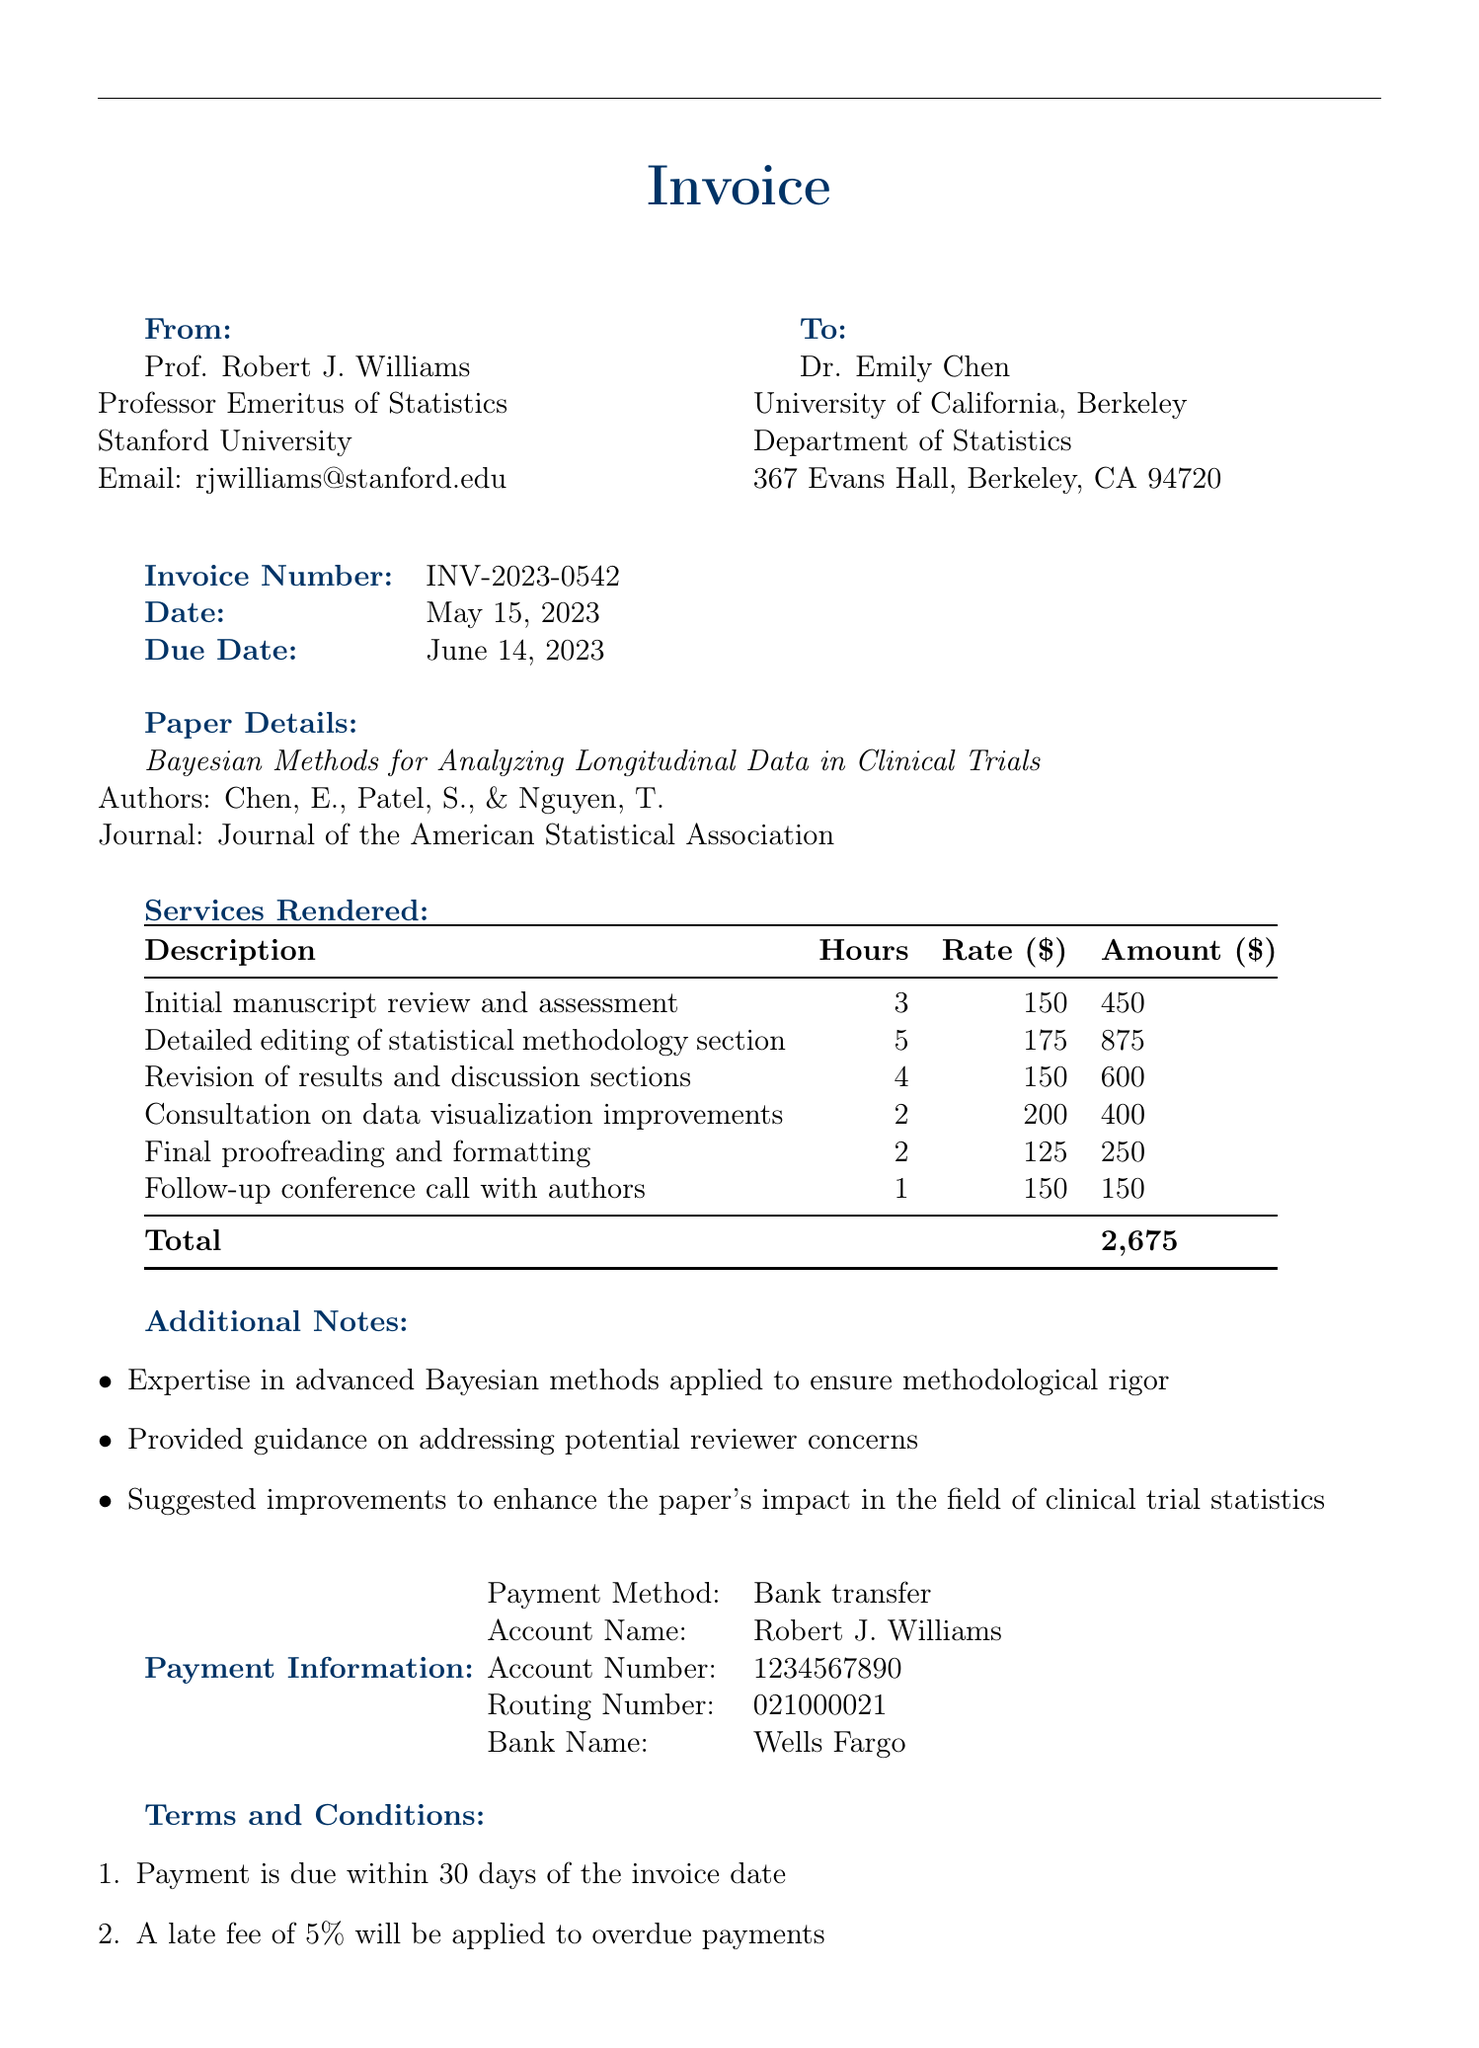What is the invoice number? The invoice number is listed clearly at the top of the document.
Answer: INV-2023-0542 Who is the client? The document specifies the client’s name and institution.
Answer: Dr. Emily Chen What is the total amount due? The total amount is mentioned at the end of the invoice.
Answer: $2,675 How many hours were spent on detailed editing of the statistical methodology section? This information is found in the table of services rendered.
Answer: 5 What is the payment method specified in the invoice? The payment method is stated under the payment information section.
Answer: Bank transfer What is the due date for the payment? The due date is provided alongside the invoice date in the document.
Answer: June 14, 2023 What is one of the additional notes regarding the services provided? Additional notes detail specific contributions made during the editing process.
Answer: Suggested improvements to enhance the paper's impact in the field of clinical trial statistics Which section involved a follow-up conference call? The services rendered section notes the specific service related to a conference call.
Answer: Follow-up conference call with authors What is the late fee percentage applied to overdue payments? The terms and conditions state the specifics of the late fee.
Answer: 5% 